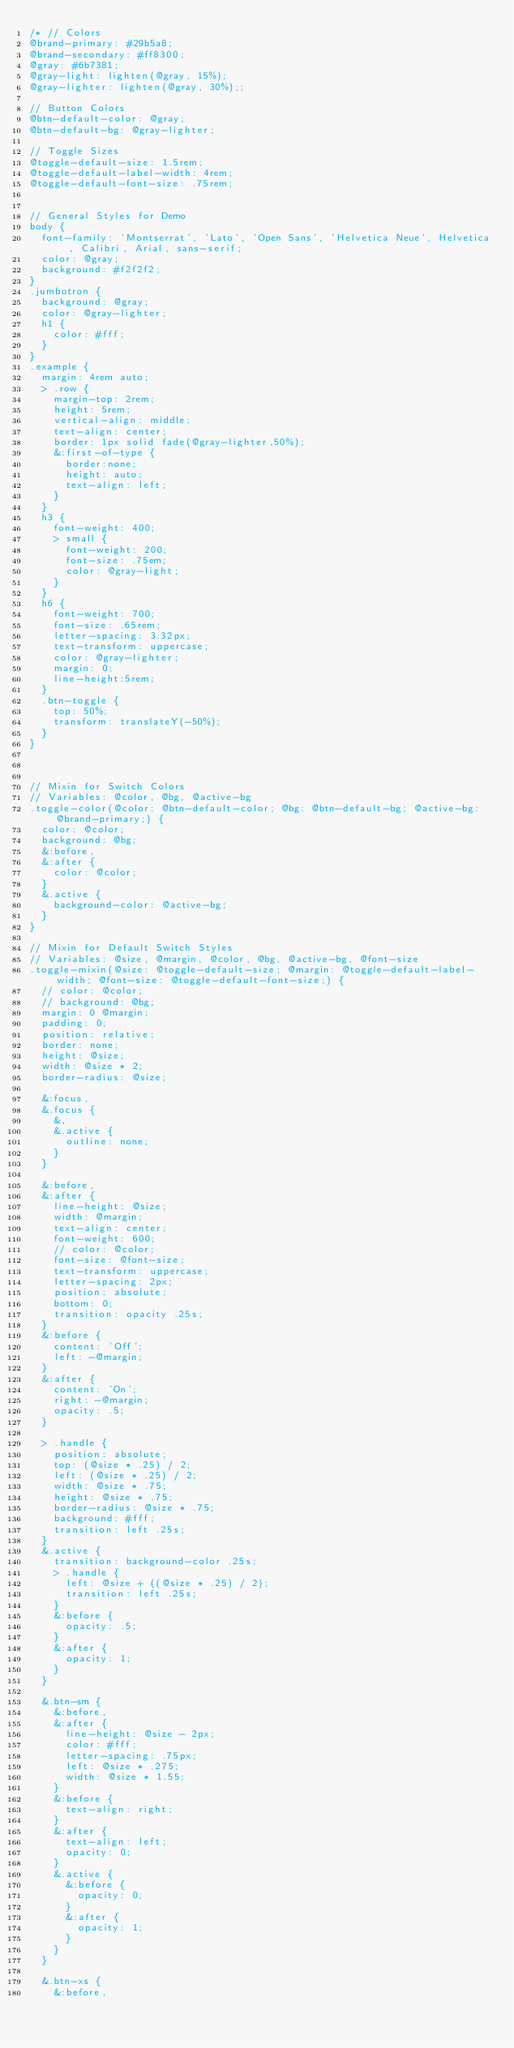<code> <loc_0><loc_0><loc_500><loc_500><_CSS_>/* // Colors
@brand-primary: #29b5a8;
@brand-secondary: #ff8300;
@gray: #6b7381;
@gray-light: lighten(@gray, 15%);
@gray-lighter: lighten(@gray, 30%);;

// Button Colors
@btn-default-color: @gray;
@btn-default-bg: @gray-lighter;

// Toggle Sizes
@toggle-default-size: 1.5rem;
@toggle-default-label-width: 4rem;
@toggle-default-font-size: .75rem;


// General Styles for Demo
body {
	font-family: 'Montserrat', 'Lato', 'Open Sans', 'Helvetica Neue', Helvetica, Calibri, Arial, sans-serif;
	color: @gray;
	background: #f2f2f2;
}
.jumbotron {
  background: @gray;
  color: @gray-lighter;
  h1 {
    color: #fff;
  }
}
.example {
  margin: 4rem auto;
  > .row {
    margin-top: 2rem;
    height: 5rem;
    vertical-align: middle;
    text-align: center;
    border: 1px solid fade(@gray-lighter,50%);
    &:first-of-type {
      border:none;
      height: auto;
      text-align: left;
    }
  }
  h3 {
    font-weight: 400;
    > small {
      font-weight: 200;
      font-size: .75em;
      color: @gray-light;
    }
  }
  h6 {
    font-weight: 700;
    font-size: .65rem;
    letter-spacing: 3.32px;
    text-transform: uppercase;
    color: @gray-lighter;
    margin: 0;
    line-height:5rem;
  }
  .btn-toggle {
    top: 50%;
    transform: translateY(-50%);
  }
}



// Mixin for Switch Colors
// Variables: @color, @bg, @active-bg
.toggle-color(@color: @btn-default-color; @bg: @btn-default-bg; @active-bg: @brand-primary;) {
  color: @color;
  background: @bg;
  &:before,
  &:after {
    color: @color;
  }
  &.active {
    background-color: @active-bg;
  }
}

// Mixin for Default Switch Styles
// Variables: @size, @margin, @color, @bg, @active-bg, @font-size
.toggle-mixin(@size: @toggle-default-size; @margin: @toggle-default-label-width; @font-size: @toggle-default-font-size;) {
  // color: @color;
  // background: @bg;
  margin: 0 @margin;
  padding: 0;
  position: relative;
  border: none;
  height: @size;
  width: @size * 2;
  border-radius: @size;
  
  &:focus,
  &.focus {
    &,
    &.active {
      outline: none;
    }
  }
  
  &:before,
  &:after {
    line-height: @size;
    width: @margin;
    text-align: center;
    font-weight: 600;
    // color: @color;
    font-size: @font-size;
    text-transform: uppercase;
    letter-spacing: 2px;
    position: absolute;
    bottom: 0;
    transition: opacity .25s;
  }
  &:before {
    content: 'Off';
    left: -@margin;
  }
  &:after {
    content: 'On';
    right: -@margin;
    opacity: .5;
  }
  
  > .handle {
    position: absolute;
    top: (@size * .25) / 2;
    left: (@size * .25) / 2;
    width: @size * .75;
    height: @size * .75;
    border-radius: @size * .75;
    background: #fff;
    transition: left .25s;
  }
  &.active {
    transition: background-color .25s;
    > .handle {
      left: @size + ((@size * .25) / 2);
      transition: left .25s;
    }
    &:before {
      opacity: .5;
    }
    &:after {
      opacity: 1;
    }
  }
  
  &.btn-sm {
    &:before,
    &:after {
      line-height: @size - 2px;
      color: #fff;
      letter-spacing: .75px;
      left: @size * .275;
      width: @size * 1.55;
    }
    &:before {
      text-align: right;
    }
    &:after {
      text-align: left;
      opacity: 0;
    }
    &.active {
      &:before {
        opacity: 0;
      }
      &:after {
        opacity: 1;
      }
    }
  }
  
  &.btn-xs {
    &:before,</code> 